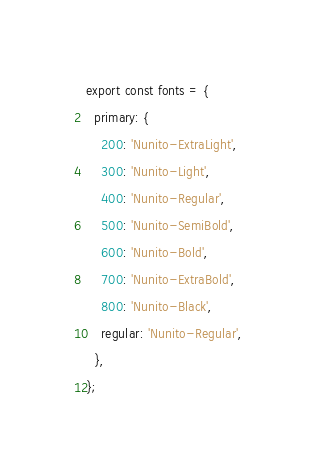Convert code to text. <code><loc_0><loc_0><loc_500><loc_500><_JavaScript_>export const fonts = {
  primary: {
    200: 'Nunito-ExtraLight',
    300: 'Nunito-Light',
    400: 'Nunito-Regular',
    500: 'Nunito-SemiBold',
    600: 'Nunito-Bold',
    700: 'Nunito-ExtraBold',
    800: 'Nunito-Black',
    regular: 'Nunito-Regular',
  },
};
</code> 